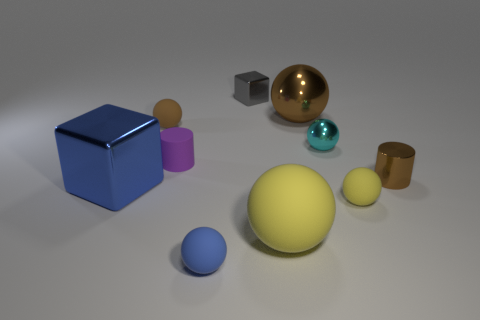There is a block in front of the purple cylinder; does it have the same size as the brown metallic sphere?
Provide a succinct answer. Yes. There is a large object that is in front of the blue metallic object; what material is it?
Give a very brief answer. Rubber. Is the number of small gray metallic blocks in front of the blue rubber sphere the same as the number of big yellow balls that are in front of the blue cube?
Your answer should be very brief. No. There is a large rubber thing that is the same shape as the tiny yellow rubber object; what is its color?
Your answer should be compact. Yellow. Is there any other thing that is the same color as the rubber cylinder?
Offer a very short reply. No. How many rubber objects are either yellow things or tiny brown objects?
Your response must be concise. 3. Is the color of the large metallic ball the same as the small shiny cylinder?
Provide a succinct answer. Yes. Is the number of small matte objects on the left side of the cyan metal object greater than the number of large yellow matte balls?
Offer a very short reply. Yes. How many other objects are the same material as the large brown sphere?
Keep it short and to the point. 4. What number of tiny things are either balls or gray blocks?
Provide a succinct answer. 5. 